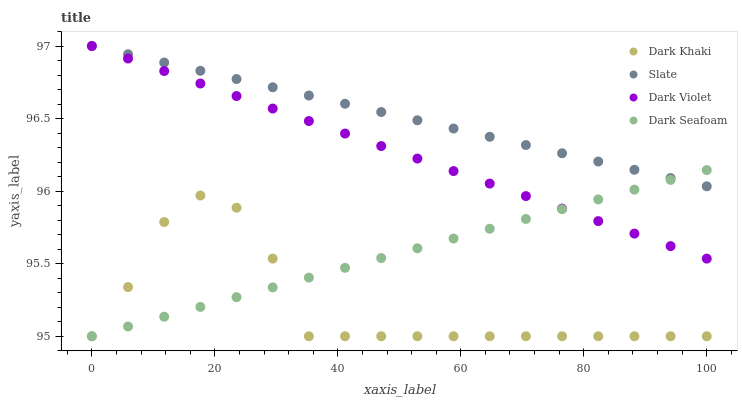Does Dark Khaki have the minimum area under the curve?
Answer yes or no. Yes. Does Slate have the maximum area under the curve?
Answer yes or no. Yes. Does Dark Seafoam have the minimum area under the curve?
Answer yes or no. No. Does Dark Seafoam have the maximum area under the curve?
Answer yes or no. No. Is Dark Violet the smoothest?
Answer yes or no. Yes. Is Dark Khaki the roughest?
Answer yes or no. Yes. Is Slate the smoothest?
Answer yes or no. No. Is Slate the roughest?
Answer yes or no. No. Does Dark Khaki have the lowest value?
Answer yes or no. Yes. Does Slate have the lowest value?
Answer yes or no. No. Does Dark Violet have the highest value?
Answer yes or no. Yes. Does Dark Seafoam have the highest value?
Answer yes or no. No. Is Dark Khaki less than Slate?
Answer yes or no. Yes. Is Slate greater than Dark Khaki?
Answer yes or no. Yes. Does Dark Violet intersect Slate?
Answer yes or no. Yes. Is Dark Violet less than Slate?
Answer yes or no. No. Is Dark Violet greater than Slate?
Answer yes or no. No. Does Dark Khaki intersect Slate?
Answer yes or no. No. 